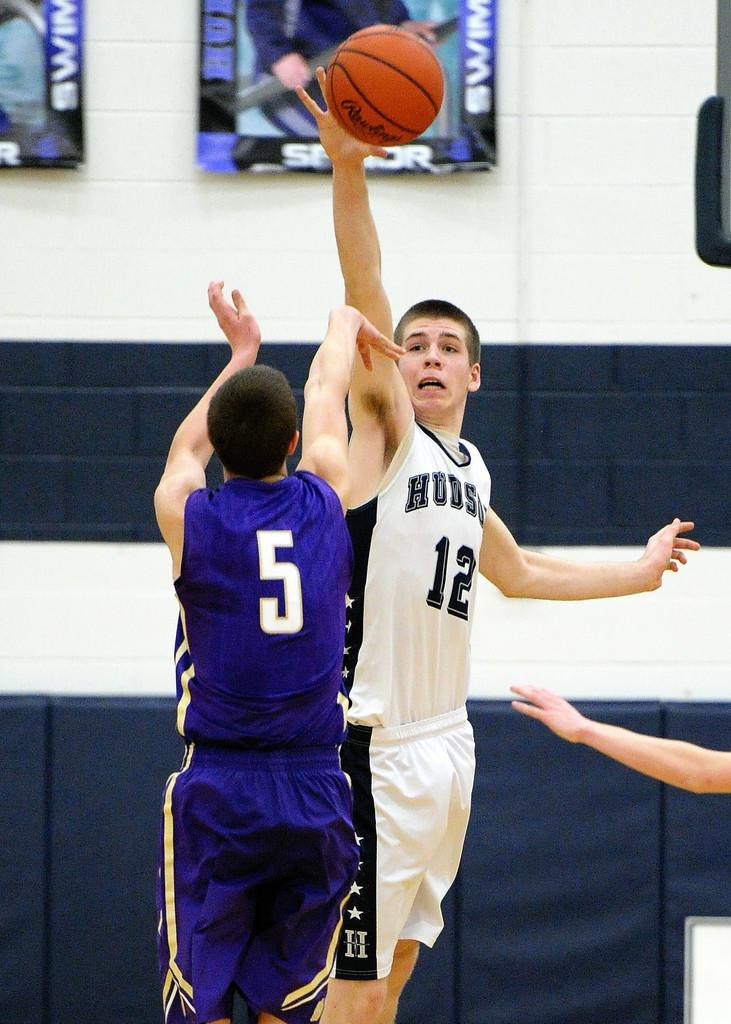<image>
Provide a brief description of the given image. hudson basketball player #12 trying to block shot from purple player #5 